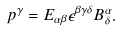<formula> <loc_0><loc_0><loc_500><loc_500>p ^ { \gamma } = E _ { \alpha \beta } \epsilon ^ { \beta \gamma \delta } B _ { \delta } ^ { \alpha } .</formula> 